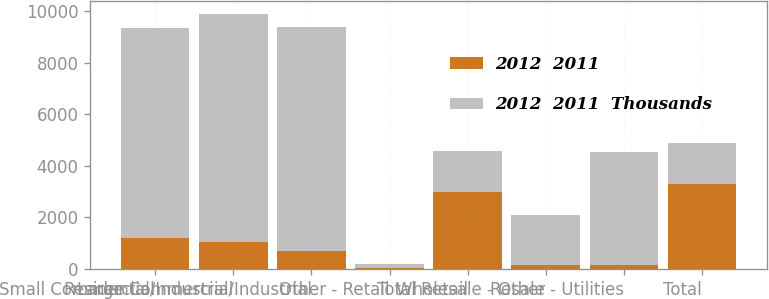Convert chart. <chart><loc_0><loc_0><loc_500><loc_500><stacked_bar_chart><ecel><fcel>Residential<fcel>Small Commercial/Industrial<fcel>Large Commercial/Industrial<fcel>Other - Retail<fcel>Total Retail<fcel>Wholesale - Other<fcel>Resale - Utilities<fcel>Total<nl><fcel>2012  2011<fcel>1208.6<fcel>1048<fcel>711.9<fcel>23.4<fcel>2991.9<fcel>143.7<fcel>143.2<fcel>3307.2<nl><fcel>2012  2011  Thousands<fcel>8141.9<fcel>8860.4<fcel>8673.4<fcel>152.3<fcel>1581.05<fcel>1953.5<fcel>4382.7<fcel>1581.05<nl></chart> 